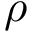<formula> <loc_0><loc_0><loc_500><loc_500>\rho</formula> 